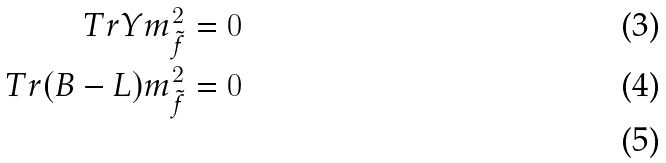<formula> <loc_0><loc_0><loc_500><loc_500>T r Y m _ { \tilde { f } } ^ { 2 } & = 0 \\ T r ( B - L ) m _ { \tilde { f } } ^ { 2 } & = 0 \\</formula> 